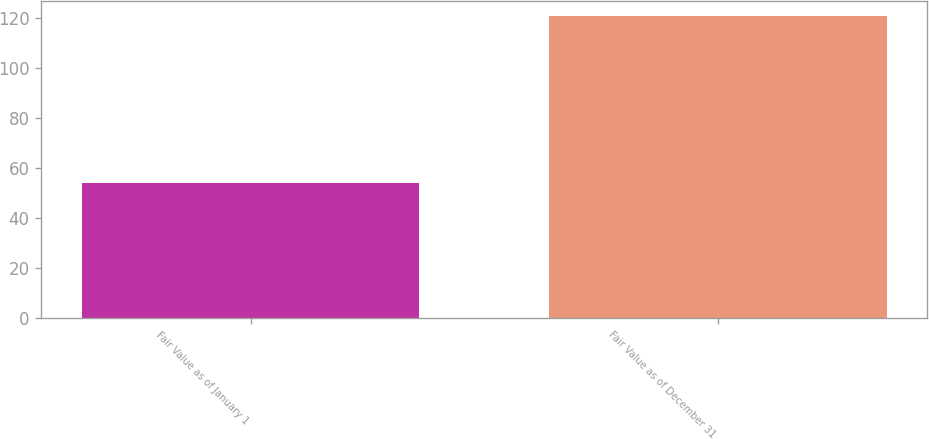Convert chart. <chart><loc_0><loc_0><loc_500><loc_500><bar_chart><fcel>Fair Value as of January 1<fcel>Fair Value as of December 31<nl><fcel>54<fcel>121<nl></chart> 